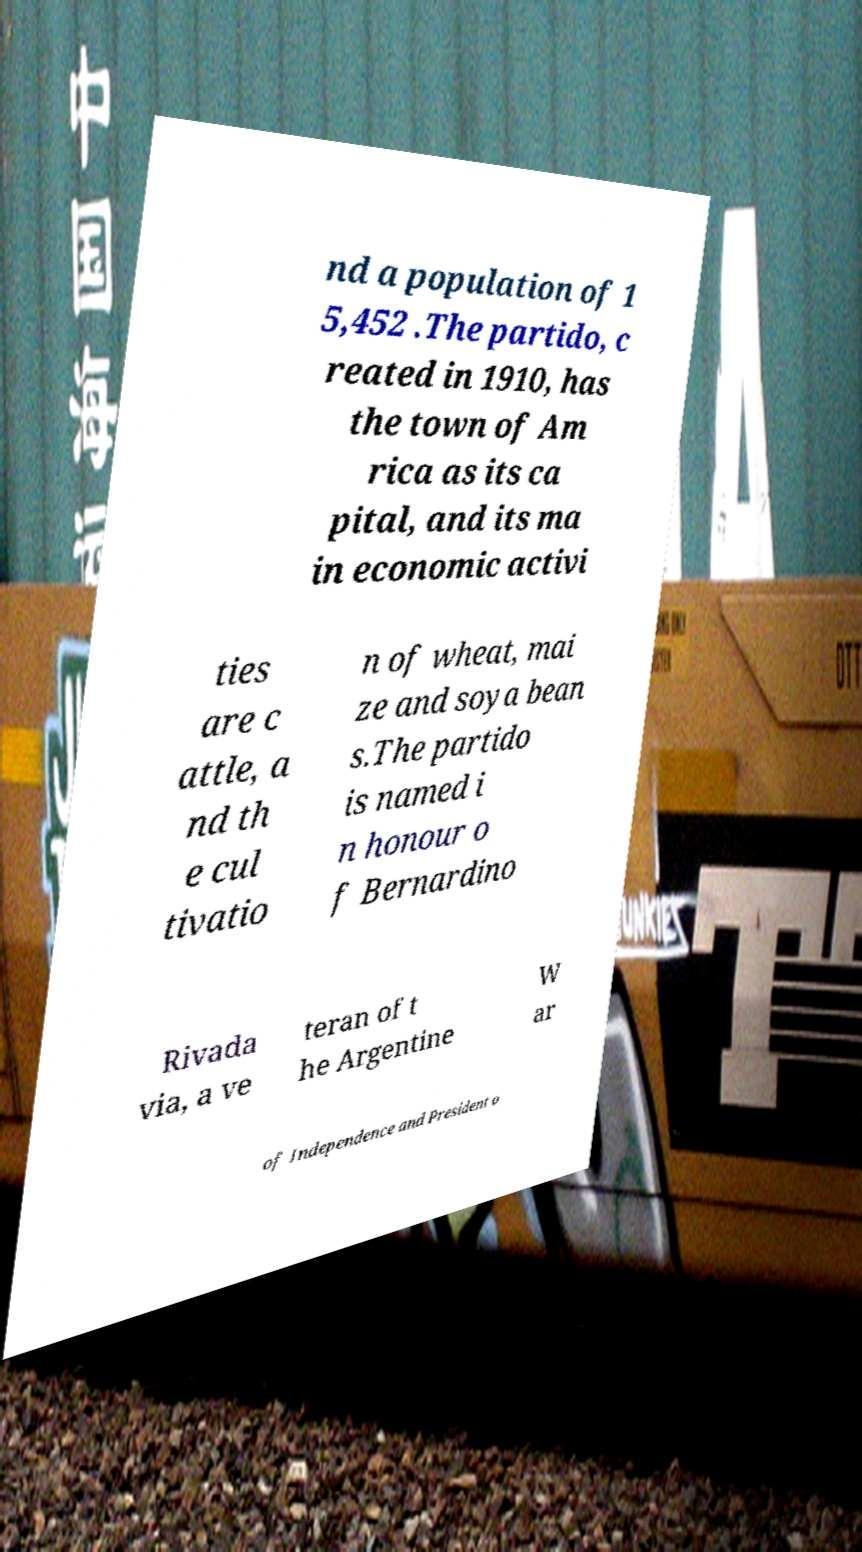I need the written content from this picture converted into text. Can you do that? nd a population of 1 5,452 .The partido, c reated in 1910, has the town of Am rica as its ca pital, and its ma in economic activi ties are c attle, a nd th e cul tivatio n of wheat, mai ze and soya bean s.The partido is named i n honour o f Bernardino Rivada via, a ve teran of t he Argentine W ar of Independence and President o 